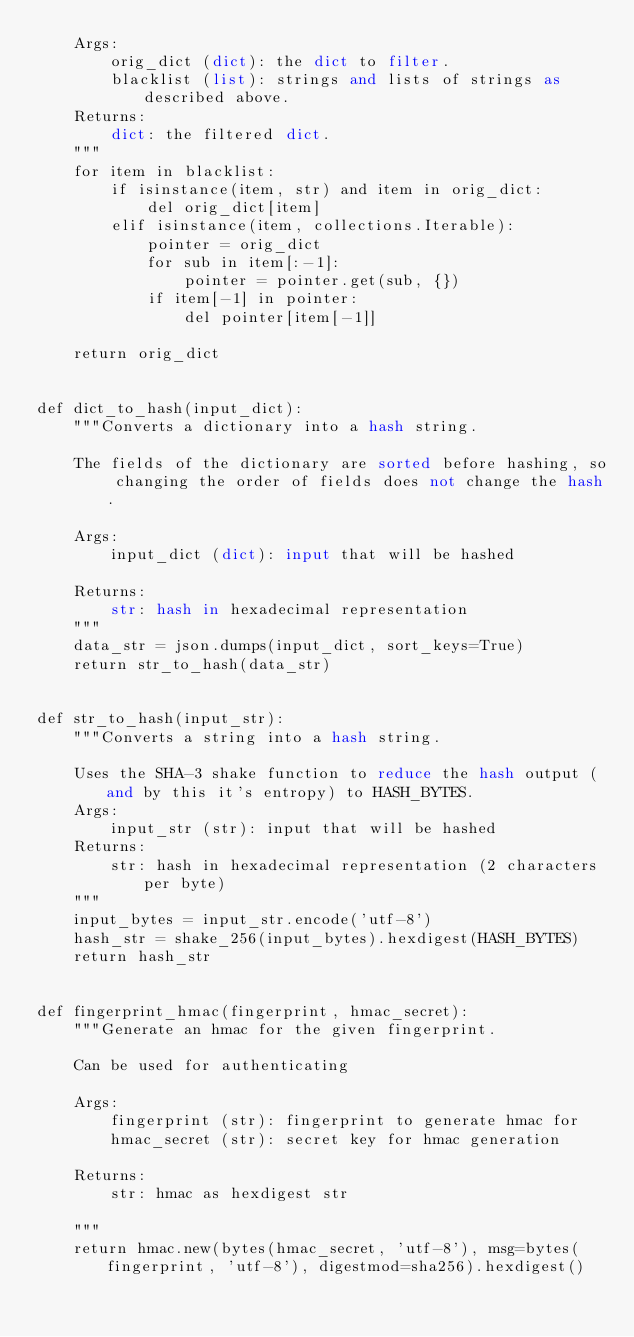<code> <loc_0><loc_0><loc_500><loc_500><_Python_>    Args:
        orig_dict (dict): the dict to filter.
        blacklist (list): strings and lists of strings as described above.
    Returns:
        dict: the filtered dict.
    """
    for item in blacklist:
        if isinstance(item, str) and item in orig_dict:
            del orig_dict[item]
        elif isinstance(item, collections.Iterable):
            pointer = orig_dict
            for sub in item[:-1]:
                pointer = pointer.get(sub, {})
            if item[-1] in pointer:
                del pointer[item[-1]]

    return orig_dict


def dict_to_hash(input_dict):
    """Converts a dictionary into a hash string.

    The fields of the dictionary are sorted before hashing, so changing the order of fields does not change the hash.

    Args:
        input_dict (dict): input that will be hashed

    Returns:
        str: hash in hexadecimal representation
    """
    data_str = json.dumps(input_dict, sort_keys=True)
    return str_to_hash(data_str)


def str_to_hash(input_str):
    """Converts a string into a hash string.

    Uses the SHA-3 shake function to reduce the hash output (and by this it's entropy) to HASH_BYTES.
    Args:
        input_str (str): input that will be hashed
    Returns:
        str: hash in hexadecimal representation (2 characters per byte)
    """
    input_bytes = input_str.encode('utf-8')
    hash_str = shake_256(input_bytes).hexdigest(HASH_BYTES)
    return hash_str


def fingerprint_hmac(fingerprint, hmac_secret):
    """Generate an hmac for the given fingerprint.

    Can be used for authenticating

    Args:
        fingerprint (str): fingerprint to generate hmac for
        hmac_secret (str): secret key for hmac generation

    Returns:
        str: hmac as hexdigest str

    """
    return hmac.new(bytes(hmac_secret, 'utf-8'), msg=bytes(fingerprint, 'utf-8'), digestmod=sha256).hexdigest()
</code> 